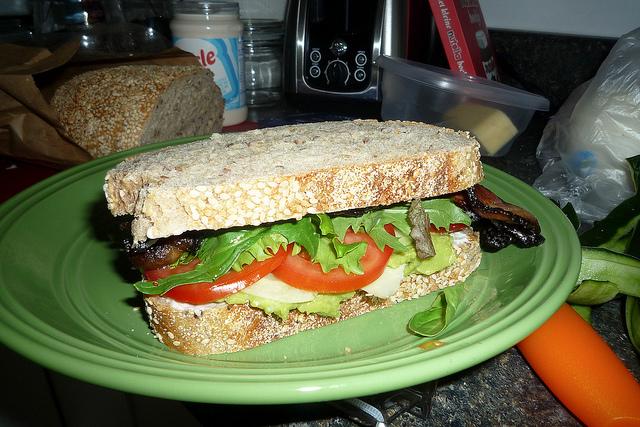What vegetables are on the sandwich?
Write a very short answer. Lettuce and tomato. Is here tomatoes in the sandwich?
Write a very short answer. Yes. Does this meal look healthy?
Quick response, please. Yes. Does this look like a messy meal?
Give a very brief answer. No. Is the sandwich made with white or wheat bread?
Keep it brief. Wheat. What color is the plate?
Answer briefly. Green. 